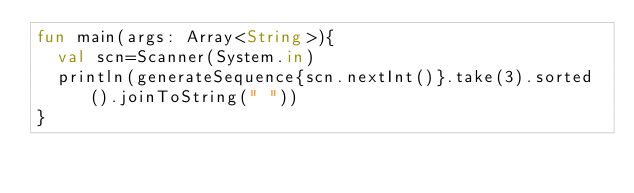Convert code to text. <code><loc_0><loc_0><loc_500><loc_500><_Kotlin_>fun main(args: Array<String>){
  val scn=Scanner(System.in)
  println(generateSequence{scn.nextInt()}.take(3).sorted().joinToString(" "))
}

</code> 